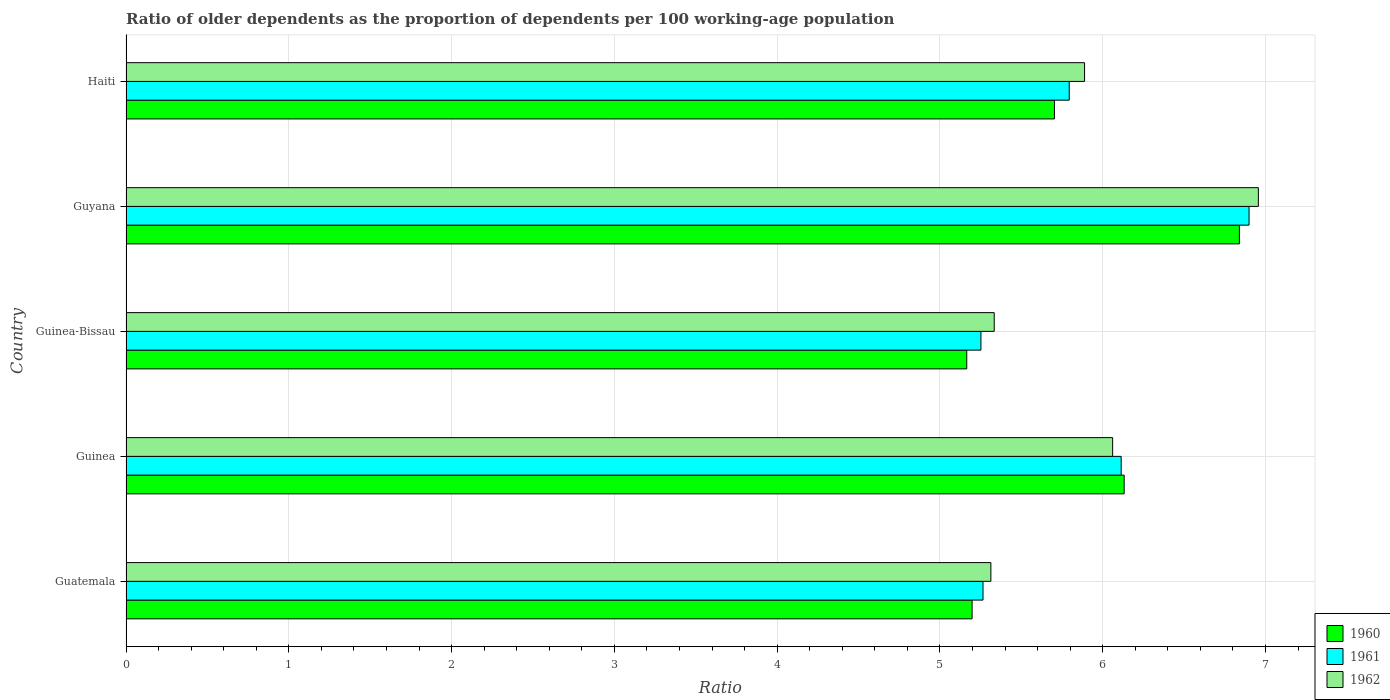How many groups of bars are there?
Offer a very short reply. 5. Are the number of bars on each tick of the Y-axis equal?
Your response must be concise. Yes. How many bars are there on the 5th tick from the top?
Keep it short and to the point. 3. How many bars are there on the 3rd tick from the bottom?
Your answer should be very brief. 3. What is the label of the 1st group of bars from the top?
Make the answer very short. Haiti. In how many cases, is the number of bars for a given country not equal to the number of legend labels?
Offer a terse response. 0. What is the age dependency ratio(old) in 1962 in Haiti?
Offer a terse response. 5.89. Across all countries, what is the maximum age dependency ratio(old) in 1961?
Your answer should be compact. 6.9. Across all countries, what is the minimum age dependency ratio(old) in 1960?
Give a very brief answer. 5.16. In which country was the age dependency ratio(old) in 1961 maximum?
Ensure brevity in your answer.  Guyana. In which country was the age dependency ratio(old) in 1962 minimum?
Provide a short and direct response. Guatemala. What is the total age dependency ratio(old) in 1961 in the graph?
Offer a very short reply. 29.32. What is the difference between the age dependency ratio(old) in 1960 in Guinea-Bissau and that in Haiti?
Offer a very short reply. -0.54. What is the difference between the age dependency ratio(old) in 1962 in Guinea-Bissau and the age dependency ratio(old) in 1961 in Guinea?
Provide a succinct answer. -0.78. What is the average age dependency ratio(old) in 1960 per country?
Your response must be concise. 5.81. What is the difference between the age dependency ratio(old) in 1962 and age dependency ratio(old) in 1961 in Guinea-Bissau?
Ensure brevity in your answer.  0.08. What is the ratio of the age dependency ratio(old) in 1960 in Guatemala to that in Guinea-Bissau?
Ensure brevity in your answer.  1.01. Is the age dependency ratio(old) in 1961 in Guinea less than that in Guinea-Bissau?
Your response must be concise. No. Is the difference between the age dependency ratio(old) in 1962 in Guatemala and Haiti greater than the difference between the age dependency ratio(old) in 1961 in Guatemala and Haiti?
Keep it short and to the point. No. What is the difference between the highest and the second highest age dependency ratio(old) in 1962?
Your response must be concise. 0.9. What is the difference between the highest and the lowest age dependency ratio(old) in 1961?
Keep it short and to the point. 1.65. In how many countries, is the age dependency ratio(old) in 1960 greater than the average age dependency ratio(old) in 1960 taken over all countries?
Offer a terse response. 2. What does the 2nd bar from the top in Guinea-Bissau represents?
Your answer should be very brief. 1961. Is it the case that in every country, the sum of the age dependency ratio(old) in 1960 and age dependency ratio(old) in 1961 is greater than the age dependency ratio(old) in 1962?
Make the answer very short. Yes. How many bars are there?
Your answer should be very brief. 15. Are all the bars in the graph horizontal?
Your answer should be very brief. Yes. How many countries are there in the graph?
Your answer should be compact. 5. Are the values on the major ticks of X-axis written in scientific E-notation?
Keep it short and to the point. No. How are the legend labels stacked?
Your answer should be compact. Vertical. What is the title of the graph?
Offer a terse response. Ratio of older dependents as the proportion of dependents per 100 working-age population. Does "1997" appear as one of the legend labels in the graph?
Your answer should be very brief. No. What is the label or title of the X-axis?
Keep it short and to the point. Ratio. What is the Ratio of 1960 in Guatemala?
Offer a very short reply. 5.2. What is the Ratio in 1961 in Guatemala?
Give a very brief answer. 5.26. What is the Ratio of 1962 in Guatemala?
Your answer should be compact. 5.31. What is the Ratio of 1960 in Guinea?
Make the answer very short. 6.13. What is the Ratio in 1961 in Guinea?
Your answer should be very brief. 6.11. What is the Ratio in 1962 in Guinea?
Your answer should be very brief. 6.06. What is the Ratio in 1960 in Guinea-Bissau?
Offer a terse response. 5.16. What is the Ratio in 1961 in Guinea-Bissau?
Offer a terse response. 5.25. What is the Ratio in 1962 in Guinea-Bissau?
Offer a terse response. 5.33. What is the Ratio in 1960 in Guyana?
Make the answer very short. 6.84. What is the Ratio of 1961 in Guyana?
Keep it short and to the point. 6.9. What is the Ratio in 1962 in Guyana?
Provide a short and direct response. 6.96. What is the Ratio in 1960 in Haiti?
Give a very brief answer. 5.7. What is the Ratio in 1961 in Haiti?
Make the answer very short. 5.79. What is the Ratio in 1962 in Haiti?
Your answer should be very brief. 5.89. Across all countries, what is the maximum Ratio of 1960?
Your answer should be very brief. 6.84. Across all countries, what is the maximum Ratio of 1961?
Your answer should be very brief. 6.9. Across all countries, what is the maximum Ratio of 1962?
Your response must be concise. 6.96. Across all countries, what is the minimum Ratio in 1960?
Your answer should be very brief. 5.16. Across all countries, what is the minimum Ratio in 1961?
Offer a very short reply. 5.25. Across all countries, what is the minimum Ratio in 1962?
Provide a short and direct response. 5.31. What is the total Ratio of 1960 in the graph?
Offer a terse response. 29.04. What is the total Ratio of 1961 in the graph?
Your answer should be very brief. 29.32. What is the total Ratio in 1962 in the graph?
Keep it short and to the point. 29.55. What is the difference between the Ratio in 1960 in Guatemala and that in Guinea?
Offer a terse response. -0.93. What is the difference between the Ratio in 1961 in Guatemala and that in Guinea?
Your answer should be compact. -0.85. What is the difference between the Ratio in 1962 in Guatemala and that in Guinea?
Your answer should be compact. -0.75. What is the difference between the Ratio in 1960 in Guatemala and that in Guinea-Bissau?
Give a very brief answer. 0.03. What is the difference between the Ratio of 1961 in Guatemala and that in Guinea-Bissau?
Your response must be concise. 0.01. What is the difference between the Ratio in 1962 in Guatemala and that in Guinea-Bissau?
Ensure brevity in your answer.  -0.02. What is the difference between the Ratio in 1960 in Guatemala and that in Guyana?
Ensure brevity in your answer.  -1.64. What is the difference between the Ratio in 1961 in Guatemala and that in Guyana?
Your answer should be compact. -1.63. What is the difference between the Ratio in 1962 in Guatemala and that in Guyana?
Offer a terse response. -1.64. What is the difference between the Ratio of 1960 in Guatemala and that in Haiti?
Make the answer very short. -0.51. What is the difference between the Ratio of 1961 in Guatemala and that in Haiti?
Offer a very short reply. -0.53. What is the difference between the Ratio of 1962 in Guatemala and that in Haiti?
Offer a very short reply. -0.58. What is the difference between the Ratio of 1960 in Guinea and that in Guinea-Bissau?
Offer a very short reply. 0.97. What is the difference between the Ratio of 1961 in Guinea and that in Guinea-Bissau?
Offer a terse response. 0.86. What is the difference between the Ratio of 1962 in Guinea and that in Guinea-Bissau?
Make the answer very short. 0.73. What is the difference between the Ratio of 1960 in Guinea and that in Guyana?
Provide a short and direct response. -0.71. What is the difference between the Ratio in 1961 in Guinea and that in Guyana?
Give a very brief answer. -0.79. What is the difference between the Ratio of 1962 in Guinea and that in Guyana?
Keep it short and to the point. -0.9. What is the difference between the Ratio in 1960 in Guinea and that in Haiti?
Your response must be concise. 0.43. What is the difference between the Ratio in 1961 in Guinea and that in Haiti?
Your answer should be compact. 0.32. What is the difference between the Ratio of 1962 in Guinea and that in Haiti?
Offer a terse response. 0.17. What is the difference between the Ratio of 1960 in Guinea-Bissau and that in Guyana?
Your answer should be very brief. -1.67. What is the difference between the Ratio of 1961 in Guinea-Bissau and that in Guyana?
Provide a short and direct response. -1.65. What is the difference between the Ratio of 1962 in Guinea-Bissau and that in Guyana?
Keep it short and to the point. -1.62. What is the difference between the Ratio in 1960 in Guinea-Bissau and that in Haiti?
Offer a terse response. -0.54. What is the difference between the Ratio in 1961 in Guinea-Bissau and that in Haiti?
Offer a very short reply. -0.54. What is the difference between the Ratio of 1962 in Guinea-Bissau and that in Haiti?
Provide a short and direct response. -0.55. What is the difference between the Ratio of 1960 in Guyana and that in Haiti?
Make the answer very short. 1.14. What is the difference between the Ratio of 1961 in Guyana and that in Haiti?
Provide a short and direct response. 1.1. What is the difference between the Ratio of 1962 in Guyana and that in Haiti?
Your response must be concise. 1.07. What is the difference between the Ratio of 1960 in Guatemala and the Ratio of 1961 in Guinea?
Your answer should be compact. -0.92. What is the difference between the Ratio of 1960 in Guatemala and the Ratio of 1962 in Guinea?
Keep it short and to the point. -0.86. What is the difference between the Ratio of 1961 in Guatemala and the Ratio of 1962 in Guinea?
Make the answer very short. -0.8. What is the difference between the Ratio of 1960 in Guatemala and the Ratio of 1961 in Guinea-Bissau?
Keep it short and to the point. -0.05. What is the difference between the Ratio of 1960 in Guatemala and the Ratio of 1962 in Guinea-Bissau?
Your response must be concise. -0.14. What is the difference between the Ratio of 1961 in Guatemala and the Ratio of 1962 in Guinea-Bissau?
Offer a very short reply. -0.07. What is the difference between the Ratio in 1960 in Guatemala and the Ratio in 1961 in Guyana?
Your response must be concise. -1.7. What is the difference between the Ratio of 1960 in Guatemala and the Ratio of 1962 in Guyana?
Make the answer very short. -1.76. What is the difference between the Ratio of 1961 in Guatemala and the Ratio of 1962 in Guyana?
Your answer should be very brief. -1.69. What is the difference between the Ratio of 1960 in Guatemala and the Ratio of 1961 in Haiti?
Offer a terse response. -0.6. What is the difference between the Ratio of 1960 in Guatemala and the Ratio of 1962 in Haiti?
Make the answer very short. -0.69. What is the difference between the Ratio in 1961 in Guatemala and the Ratio in 1962 in Haiti?
Your answer should be compact. -0.62. What is the difference between the Ratio in 1960 in Guinea and the Ratio in 1961 in Guinea-Bissau?
Your response must be concise. 0.88. What is the difference between the Ratio of 1960 in Guinea and the Ratio of 1962 in Guinea-Bissau?
Provide a succinct answer. 0.8. What is the difference between the Ratio of 1961 in Guinea and the Ratio of 1962 in Guinea-Bissau?
Ensure brevity in your answer.  0.78. What is the difference between the Ratio of 1960 in Guinea and the Ratio of 1961 in Guyana?
Give a very brief answer. -0.77. What is the difference between the Ratio of 1960 in Guinea and the Ratio of 1962 in Guyana?
Provide a succinct answer. -0.82. What is the difference between the Ratio of 1961 in Guinea and the Ratio of 1962 in Guyana?
Offer a terse response. -0.84. What is the difference between the Ratio of 1960 in Guinea and the Ratio of 1961 in Haiti?
Keep it short and to the point. 0.34. What is the difference between the Ratio of 1960 in Guinea and the Ratio of 1962 in Haiti?
Provide a short and direct response. 0.24. What is the difference between the Ratio of 1961 in Guinea and the Ratio of 1962 in Haiti?
Ensure brevity in your answer.  0.22. What is the difference between the Ratio in 1960 in Guinea-Bissau and the Ratio in 1961 in Guyana?
Provide a short and direct response. -1.73. What is the difference between the Ratio of 1960 in Guinea-Bissau and the Ratio of 1962 in Guyana?
Your response must be concise. -1.79. What is the difference between the Ratio of 1961 in Guinea-Bissau and the Ratio of 1962 in Guyana?
Offer a very short reply. -1.7. What is the difference between the Ratio in 1960 in Guinea-Bissau and the Ratio in 1961 in Haiti?
Offer a terse response. -0.63. What is the difference between the Ratio in 1960 in Guinea-Bissau and the Ratio in 1962 in Haiti?
Make the answer very short. -0.72. What is the difference between the Ratio in 1961 in Guinea-Bissau and the Ratio in 1962 in Haiti?
Provide a succinct answer. -0.64. What is the difference between the Ratio of 1960 in Guyana and the Ratio of 1961 in Haiti?
Provide a succinct answer. 1.05. What is the difference between the Ratio of 1960 in Guyana and the Ratio of 1962 in Haiti?
Offer a very short reply. 0.95. What is the difference between the Ratio in 1961 in Guyana and the Ratio in 1962 in Haiti?
Offer a terse response. 1.01. What is the average Ratio in 1960 per country?
Make the answer very short. 5.81. What is the average Ratio in 1961 per country?
Provide a short and direct response. 5.86. What is the average Ratio in 1962 per country?
Ensure brevity in your answer.  5.91. What is the difference between the Ratio in 1960 and Ratio in 1961 in Guatemala?
Your answer should be very brief. -0.07. What is the difference between the Ratio in 1960 and Ratio in 1962 in Guatemala?
Your answer should be very brief. -0.12. What is the difference between the Ratio of 1961 and Ratio of 1962 in Guatemala?
Your response must be concise. -0.05. What is the difference between the Ratio in 1960 and Ratio in 1961 in Guinea?
Ensure brevity in your answer.  0.02. What is the difference between the Ratio in 1960 and Ratio in 1962 in Guinea?
Provide a succinct answer. 0.07. What is the difference between the Ratio in 1961 and Ratio in 1962 in Guinea?
Give a very brief answer. 0.05. What is the difference between the Ratio of 1960 and Ratio of 1961 in Guinea-Bissau?
Offer a terse response. -0.09. What is the difference between the Ratio in 1960 and Ratio in 1962 in Guinea-Bissau?
Offer a terse response. -0.17. What is the difference between the Ratio in 1961 and Ratio in 1962 in Guinea-Bissau?
Offer a very short reply. -0.08. What is the difference between the Ratio in 1960 and Ratio in 1961 in Guyana?
Provide a succinct answer. -0.06. What is the difference between the Ratio in 1960 and Ratio in 1962 in Guyana?
Provide a short and direct response. -0.12. What is the difference between the Ratio in 1961 and Ratio in 1962 in Guyana?
Make the answer very short. -0.06. What is the difference between the Ratio in 1960 and Ratio in 1961 in Haiti?
Your answer should be very brief. -0.09. What is the difference between the Ratio of 1960 and Ratio of 1962 in Haiti?
Keep it short and to the point. -0.18. What is the difference between the Ratio of 1961 and Ratio of 1962 in Haiti?
Offer a terse response. -0.09. What is the ratio of the Ratio in 1960 in Guatemala to that in Guinea?
Make the answer very short. 0.85. What is the ratio of the Ratio of 1961 in Guatemala to that in Guinea?
Your answer should be very brief. 0.86. What is the ratio of the Ratio in 1962 in Guatemala to that in Guinea?
Offer a very short reply. 0.88. What is the ratio of the Ratio in 1960 in Guatemala to that in Guinea-Bissau?
Give a very brief answer. 1.01. What is the ratio of the Ratio of 1961 in Guatemala to that in Guinea-Bissau?
Keep it short and to the point. 1. What is the ratio of the Ratio in 1962 in Guatemala to that in Guinea-Bissau?
Provide a succinct answer. 1. What is the ratio of the Ratio of 1960 in Guatemala to that in Guyana?
Keep it short and to the point. 0.76. What is the ratio of the Ratio in 1961 in Guatemala to that in Guyana?
Provide a short and direct response. 0.76. What is the ratio of the Ratio of 1962 in Guatemala to that in Guyana?
Make the answer very short. 0.76. What is the ratio of the Ratio of 1960 in Guatemala to that in Haiti?
Keep it short and to the point. 0.91. What is the ratio of the Ratio in 1961 in Guatemala to that in Haiti?
Ensure brevity in your answer.  0.91. What is the ratio of the Ratio in 1962 in Guatemala to that in Haiti?
Ensure brevity in your answer.  0.9. What is the ratio of the Ratio in 1960 in Guinea to that in Guinea-Bissau?
Keep it short and to the point. 1.19. What is the ratio of the Ratio of 1961 in Guinea to that in Guinea-Bissau?
Provide a succinct answer. 1.16. What is the ratio of the Ratio of 1962 in Guinea to that in Guinea-Bissau?
Your response must be concise. 1.14. What is the ratio of the Ratio of 1960 in Guinea to that in Guyana?
Make the answer very short. 0.9. What is the ratio of the Ratio of 1961 in Guinea to that in Guyana?
Make the answer very short. 0.89. What is the ratio of the Ratio in 1962 in Guinea to that in Guyana?
Your answer should be very brief. 0.87. What is the ratio of the Ratio of 1960 in Guinea to that in Haiti?
Provide a succinct answer. 1.08. What is the ratio of the Ratio of 1961 in Guinea to that in Haiti?
Keep it short and to the point. 1.06. What is the ratio of the Ratio of 1962 in Guinea to that in Haiti?
Offer a terse response. 1.03. What is the ratio of the Ratio in 1960 in Guinea-Bissau to that in Guyana?
Provide a short and direct response. 0.76. What is the ratio of the Ratio in 1961 in Guinea-Bissau to that in Guyana?
Provide a succinct answer. 0.76. What is the ratio of the Ratio of 1962 in Guinea-Bissau to that in Guyana?
Provide a short and direct response. 0.77. What is the ratio of the Ratio in 1960 in Guinea-Bissau to that in Haiti?
Give a very brief answer. 0.91. What is the ratio of the Ratio of 1961 in Guinea-Bissau to that in Haiti?
Provide a short and direct response. 0.91. What is the ratio of the Ratio in 1962 in Guinea-Bissau to that in Haiti?
Your response must be concise. 0.91. What is the ratio of the Ratio in 1960 in Guyana to that in Haiti?
Your response must be concise. 1.2. What is the ratio of the Ratio in 1961 in Guyana to that in Haiti?
Offer a very short reply. 1.19. What is the ratio of the Ratio in 1962 in Guyana to that in Haiti?
Your response must be concise. 1.18. What is the difference between the highest and the second highest Ratio of 1960?
Offer a very short reply. 0.71. What is the difference between the highest and the second highest Ratio of 1961?
Make the answer very short. 0.79. What is the difference between the highest and the second highest Ratio of 1962?
Provide a succinct answer. 0.9. What is the difference between the highest and the lowest Ratio of 1960?
Offer a very short reply. 1.67. What is the difference between the highest and the lowest Ratio in 1961?
Provide a succinct answer. 1.65. What is the difference between the highest and the lowest Ratio in 1962?
Ensure brevity in your answer.  1.64. 